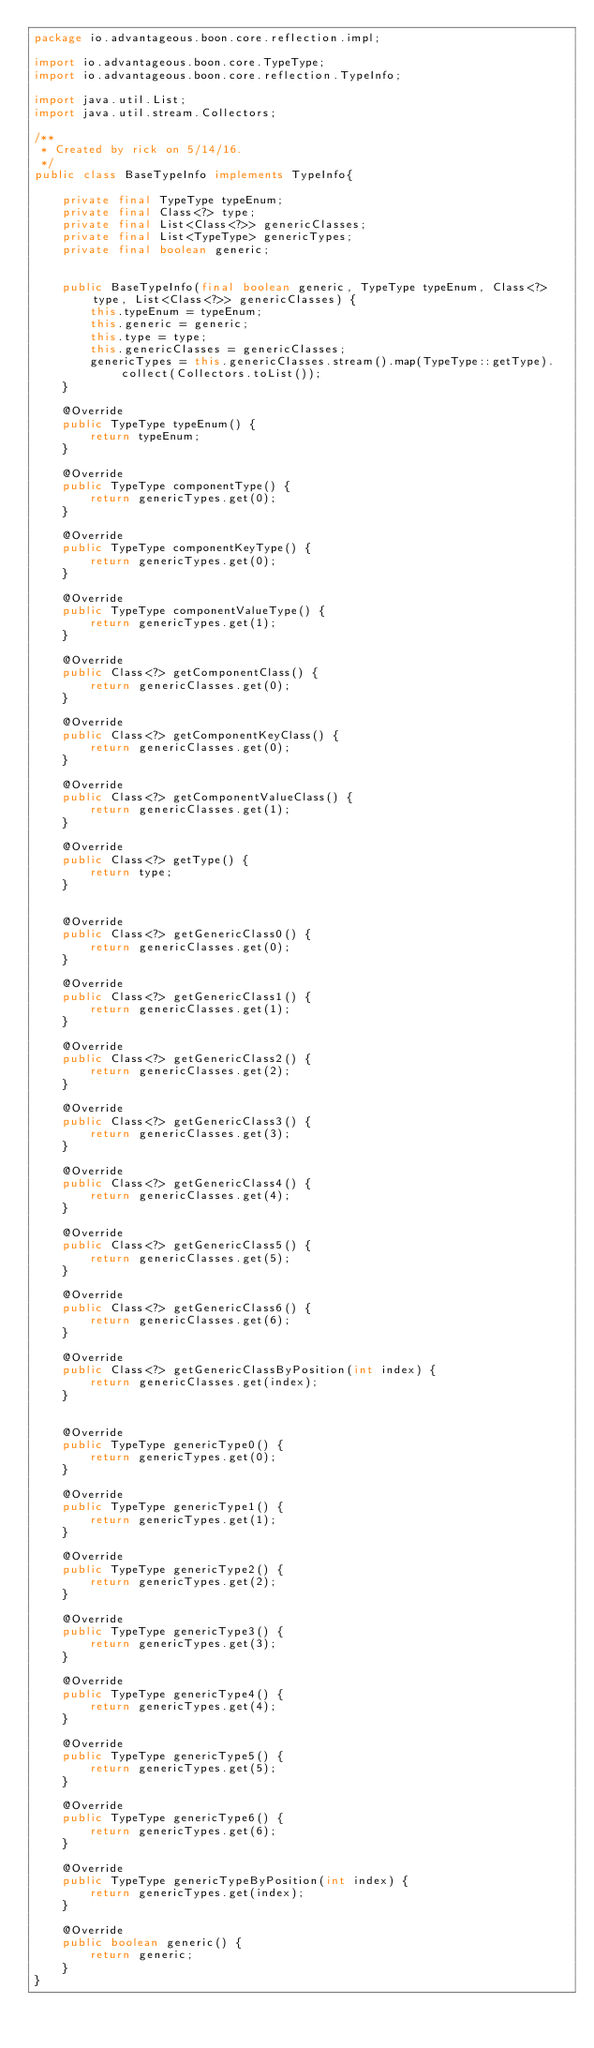<code> <loc_0><loc_0><loc_500><loc_500><_Java_>package io.advantageous.boon.core.reflection.impl;

import io.advantageous.boon.core.TypeType;
import io.advantageous.boon.core.reflection.TypeInfo;

import java.util.List;
import java.util.stream.Collectors;

/**
 * Created by rick on 5/14/16.
 */
public class BaseTypeInfo implements TypeInfo{

    private final TypeType typeEnum;
    private final Class<?> type;
    private final List<Class<?>> genericClasses;
    private final List<TypeType> genericTypes;
    private final boolean generic;


    public BaseTypeInfo(final boolean generic, TypeType typeEnum, Class<?> type, List<Class<?>> genericClasses) {
        this.typeEnum = typeEnum;
        this.generic = generic;
        this.type = type;
        this.genericClasses = genericClasses;
        genericTypes = this.genericClasses.stream().map(TypeType::getType).collect(Collectors.toList());
    }

    @Override
    public TypeType typeEnum() {
        return typeEnum;
    }

    @Override
    public TypeType componentType() {
        return genericTypes.get(0);
    }

    @Override
    public TypeType componentKeyType() {
        return genericTypes.get(0);
    }

    @Override
    public TypeType componentValueType() {
        return genericTypes.get(1);
    }

    @Override
    public Class<?> getComponentClass() {
        return genericClasses.get(0);
    }

    @Override
    public Class<?> getComponentKeyClass() {
        return genericClasses.get(0);
    }

    @Override
    public Class<?> getComponentValueClass() {
        return genericClasses.get(1);
    }

    @Override
    public Class<?> getType() {
        return type;
    }


    @Override
    public Class<?> getGenericClass0() {
        return genericClasses.get(0);
    }

    @Override
    public Class<?> getGenericClass1() {
        return genericClasses.get(1);
    }

    @Override
    public Class<?> getGenericClass2() {
        return genericClasses.get(2);
    }

    @Override
    public Class<?> getGenericClass3() {
        return genericClasses.get(3);
    }

    @Override
    public Class<?> getGenericClass4() {
        return genericClasses.get(4);
    }

    @Override
    public Class<?> getGenericClass5() {
        return genericClasses.get(5);
    }

    @Override
    public Class<?> getGenericClass6() {
        return genericClasses.get(6);
    }

    @Override
    public Class<?> getGenericClassByPosition(int index) {
        return genericClasses.get(index);
    }


    @Override
    public TypeType genericType0() {
        return genericTypes.get(0);
    }

    @Override
    public TypeType genericType1() {
        return genericTypes.get(1);
    }

    @Override
    public TypeType genericType2() {
        return genericTypes.get(2);
    }

    @Override
    public TypeType genericType3() {
        return genericTypes.get(3);
    }

    @Override
    public TypeType genericType4() {
        return genericTypes.get(4);
    }

    @Override
    public TypeType genericType5() {
        return genericTypes.get(5);
    }

    @Override
    public TypeType genericType6() {
        return genericTypes.get(6);
    }

    @Override
    public TypeType genericTypeByPosition(int index) {
        return genericTypes.get(index);
    }

    @Override
    public boolean generic() {
        return generic;
    }
}
</code> 